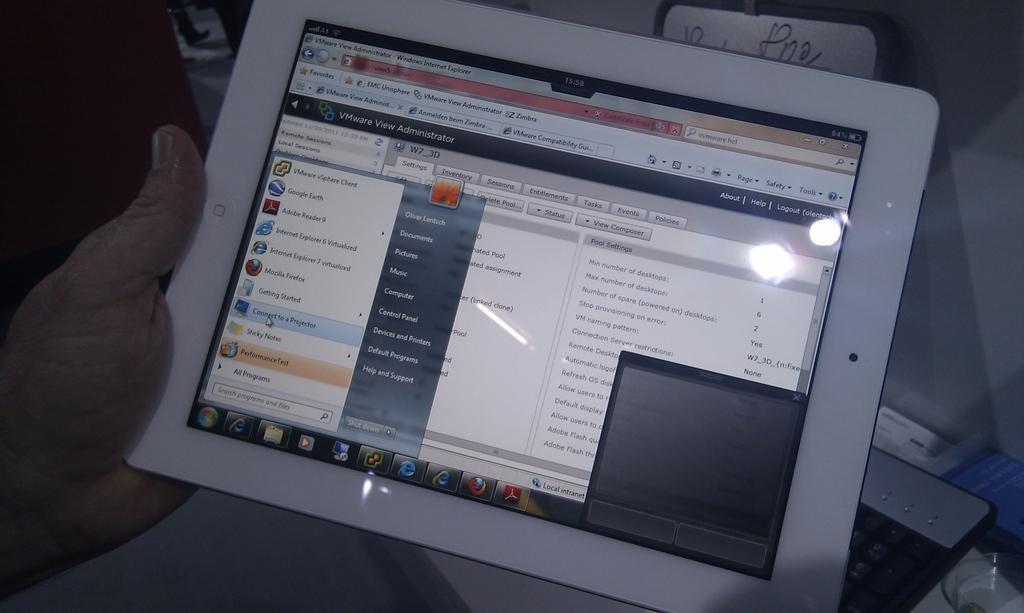Please provide a concise description of this image. In the image we can see there is a person holding a tablet and there are windows and tabs are open on the screen. 